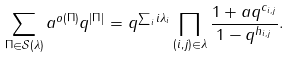<formula> <loc_0><loc_0><loc_500><loc_500>\sum _ { \Pi \in \mathcal { S } ( \lambda ) } a ^ { o ( \Pi ) } q ^ { | \Pi | } = q ^ { \sum _ { i } i \lambda _ { i } } \prod _ { ( i , j ) \in \lambda } \frac { 1 + a q ^ { c _ { i , j } } } { 1 - q ^ { h _ { i , j } } } .</formula> 